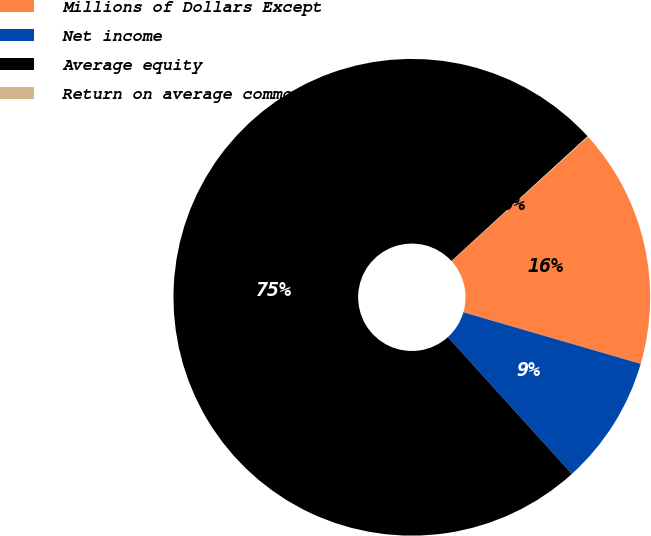Convert chart to OTSL. <chart><loc_0><loc_0><loc_500><loc_500><pie_chart><fcel>Millions of Dollars Except<fcel>Net income<fcel>Average equity<fcel>Return on average common<nl><fcel>16.26%<fcel>8.78%<fcel>74.9%<fcel>0.05%<nl></chart> 